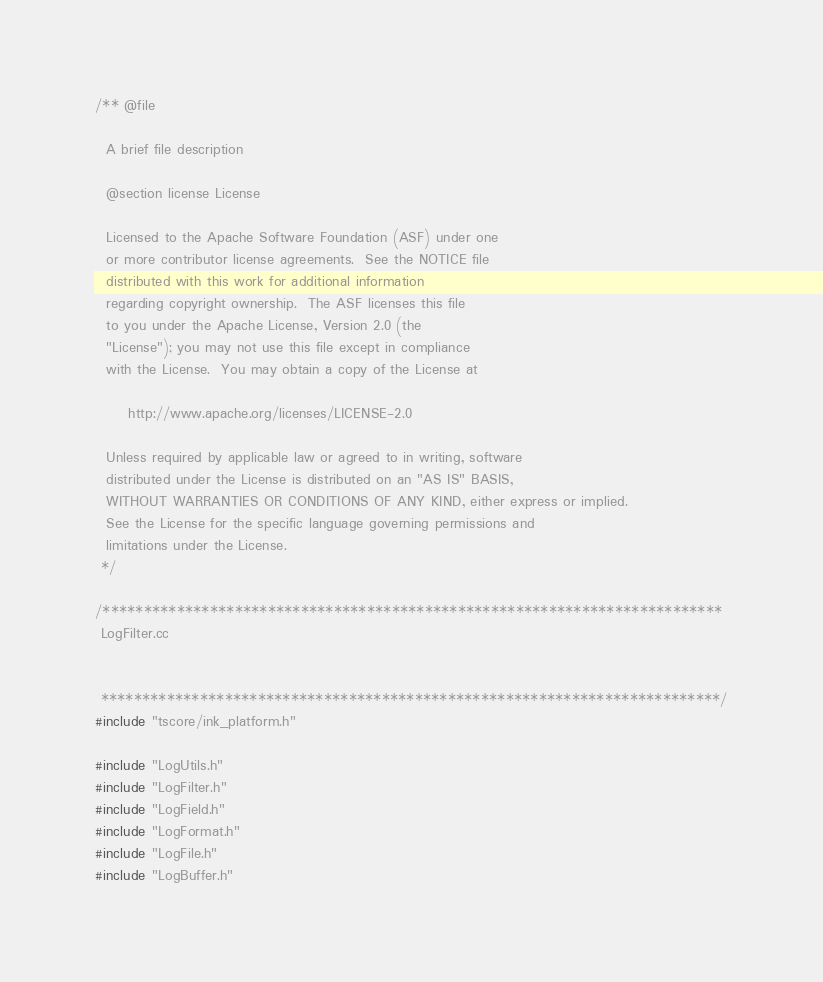<code> <loc_0><loc_0><loc_500><loc_500><_C++_>/** @file

  A brief file description

  @section license License

  Licensed to the Apache Software Foundation (ASF) under one
  or more contributor license agreements.  See the NOTICE file
  distributed with this work for additional information
  regarding copyright ownership.  The ASF licenses this file
  to you under the Apache License, Version 2.0 (the
  "License"); you may not use this file except in compliance
  with the License.  You may obtain a copy of the License at

      http://www.apache.org/licenses/LICENSE-2.0

  Unless required by applicable law or agreed to in writing, software
  distributed under the License is distributed on an "AS IS" BASIS,
  WITHOUT WARRANTIES OR CONDITIONS OF ANY KIND, either express or implied.
  See the License for the specific language governing permissions and
  limitations under the License.
 */

/***************************************************************************
 LogFilter.cc


 ***************************************************************************/
#include "tscore/ink_platform.h"

#include "LogUtils.h"
#include "LogFilter.h"
#include "LogField.h"
#include "LogFormat.h"
#include "LogFile.h"
#include "LogBuffer.h"</code> 